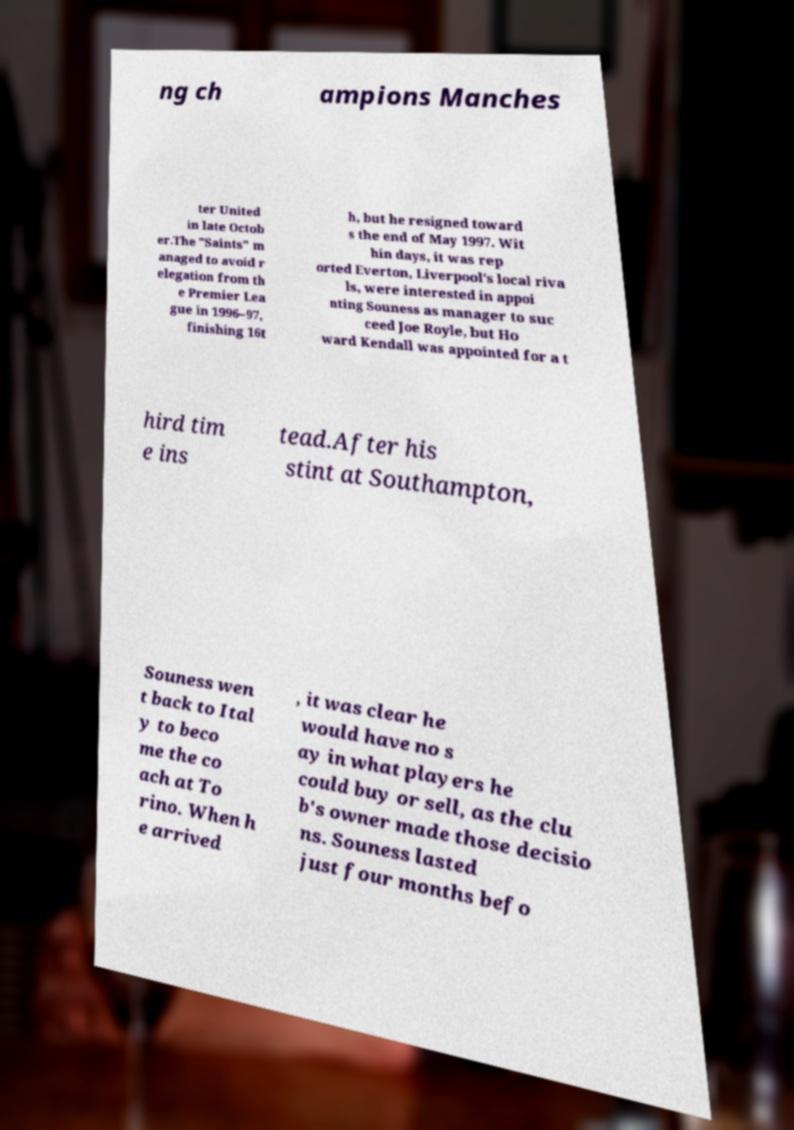What messages or text are displayed in this image? I need them in a readable, typed format. ng ch ampions Manches ter United in late Octob er.The "Saints" m anaged to avoid r elegation from th e Premier Lea gue in 1996–97, finishing 16t h, but he resigned toward s the end of May 1997. Wit hin days, it was rep orted Everton, Liverpool's local riva ls, were interested in appoi nting Souness as manager to suc ceed Joe Royle, but Ho ward Kendall was appointed for a t hird tim e ins tead.After his stint at Southampton, Souness wen t back to Ital y to beco me the co ach at To rino. When h e arrived , it was clear he would have no s ay in what players he could buy or sell, as the clu b's owner made those decisio ns. Souness lasted just four months befo 